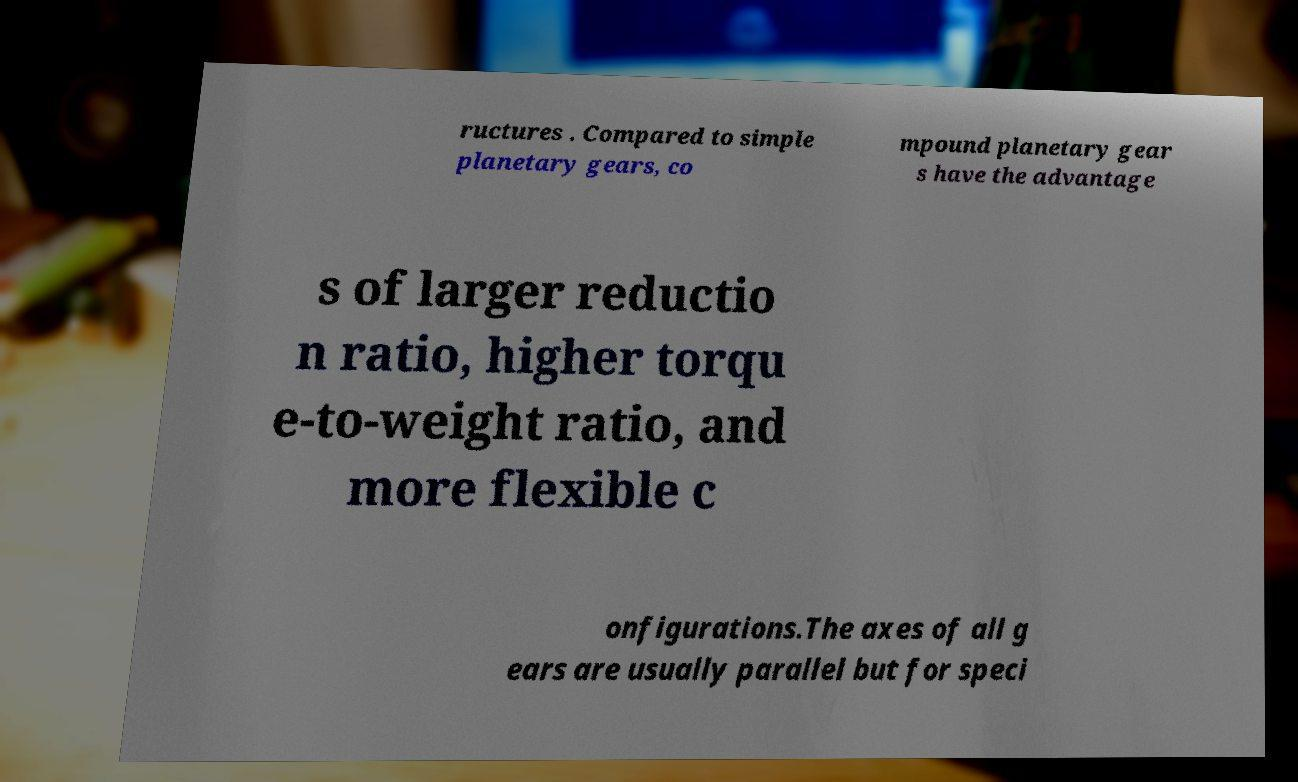Please read and relay the text visible in this image. What does it say? ructures . Compared to simple planetary gears, co mpound planetary gear s have the advantage s of larger reductio n ratio, higher torqu e-to-weight ratio, and more flexible c onfigurations.The axes of all g ears are usually parallel but for speci 